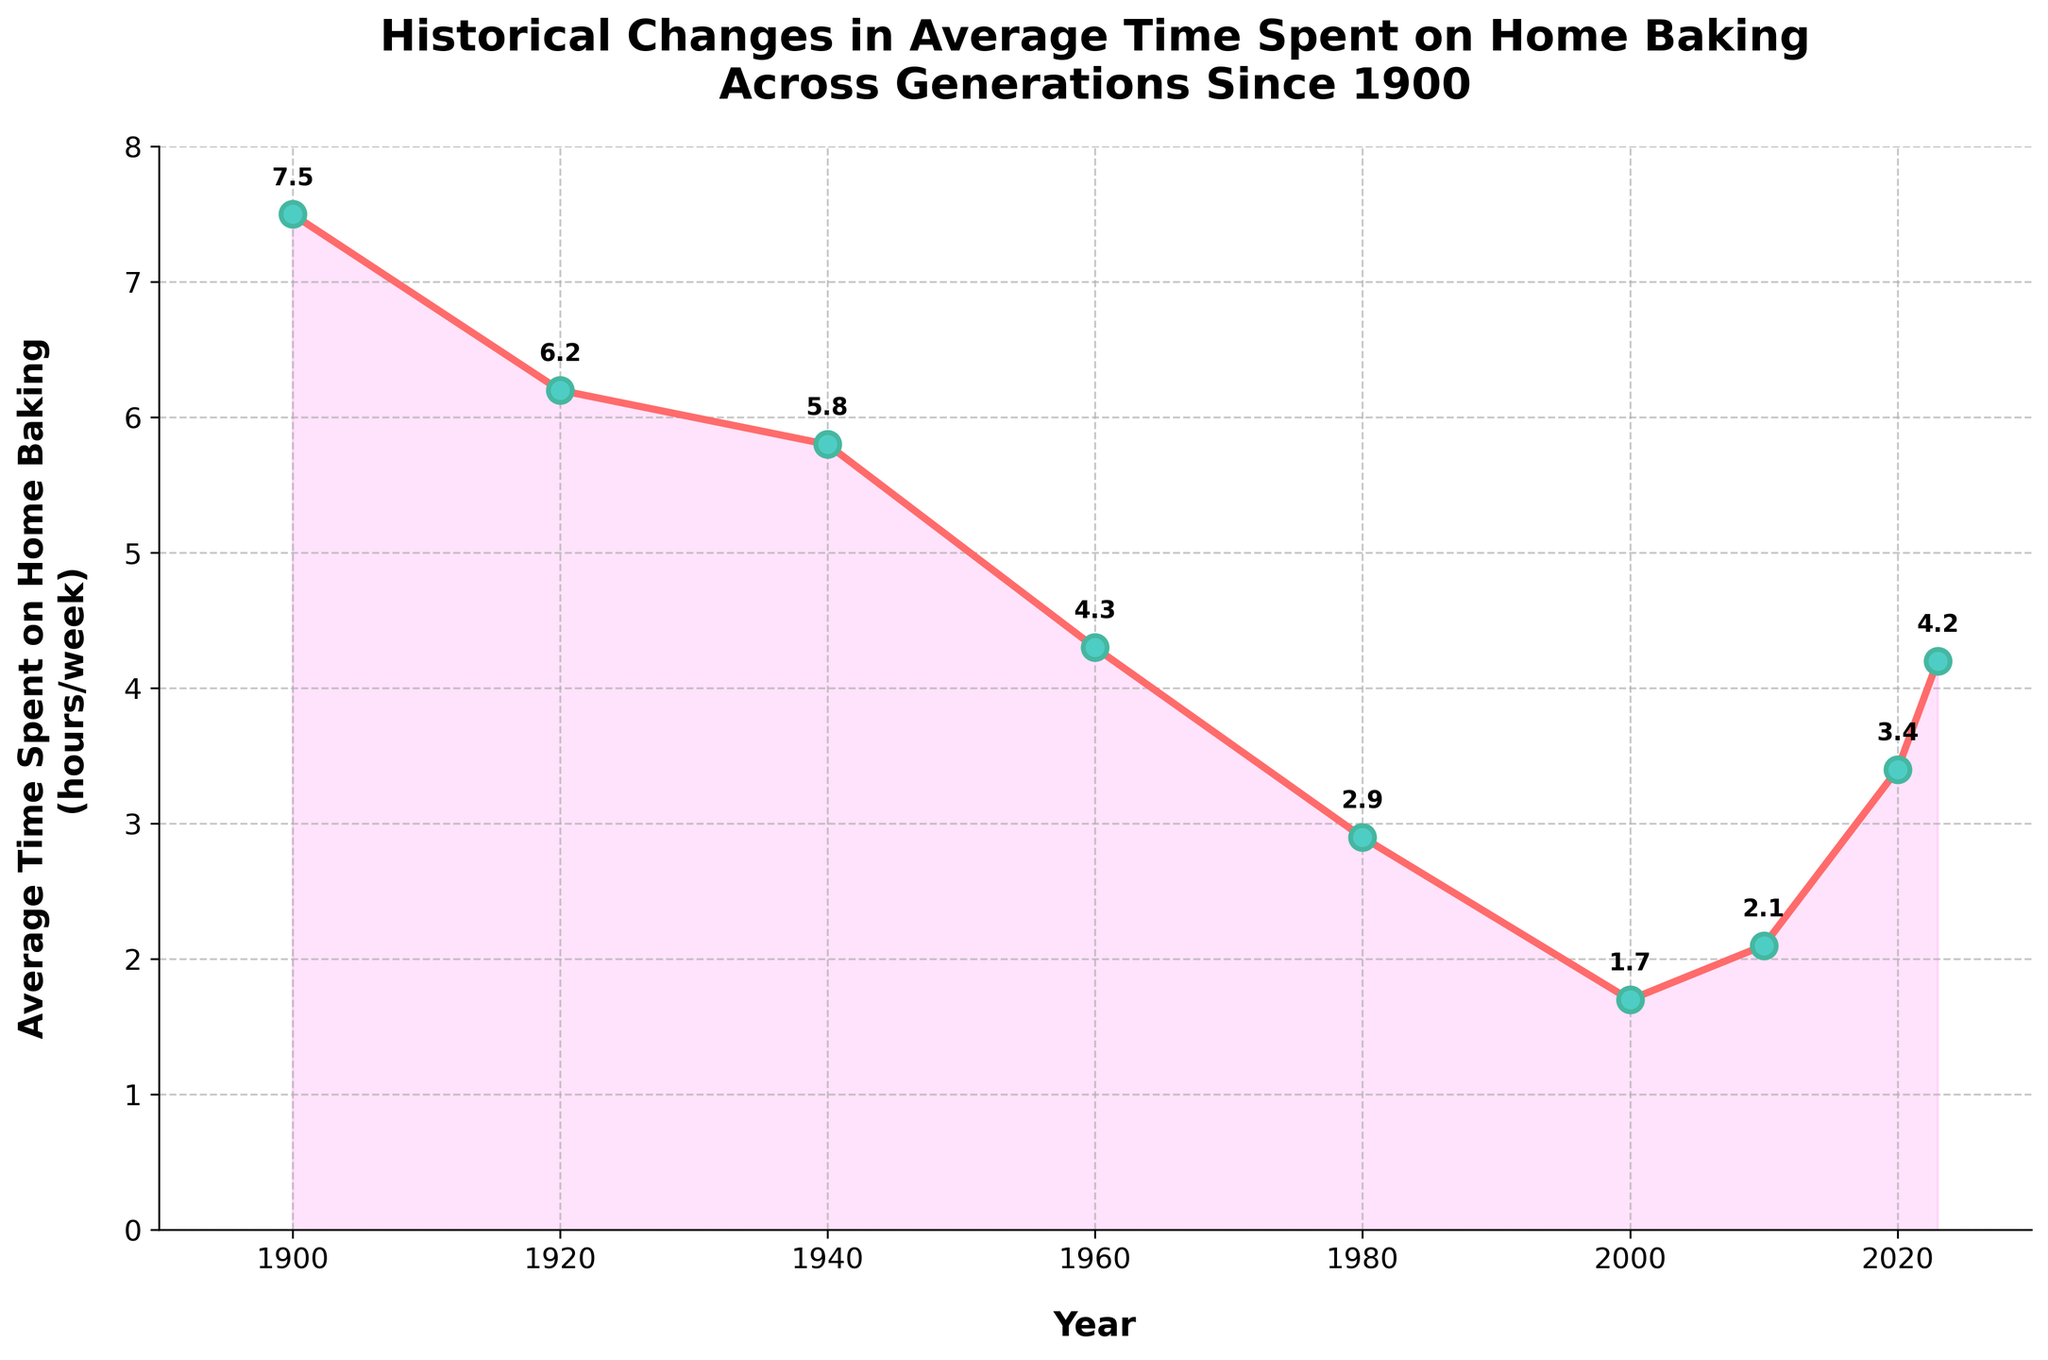What is the average time spent on home baking in 1920? Look at the y-axis value corresponding to the year 1920. The plot shows 6.2 hours/week in this year.
Answer: 6.2 hours/week In which year was the least amount of time spent on home baking? Identify the point on the graph corresponding to the lowest value. The lowest point occurs in 2000, with an average time of 1.7 hours/week.
Answer: 2000 How does the time spent on home baking in 1960 compare to that in 2023? Compare the y-axis values for the years 1960 and 2023. In 1960, it was 4.3 hours/week, and in 2023, it is 4.2 hours/week. 1960 has slightly more time spent.
Answer: 1960 is more What is the difference in time spent on home baking between 1900 and 2000? Subtract the value in 2000 (1.7 hours/week) from the value in 1900 (7.5 hours/week). 7.5 - 1.7 = 5.8 hours.
Answer: 5.8 hours Which decade saw the most significant decrease in time spent on home baking? Observe the trend of the graph and identify the steepest downward slope. The sharpest decline is between 1960 (4.3) and 1980 (2.9), a difference of 1.4 hours.
Answer: 1960 to 1980 By how many hours did the average time spent on home baking increase from 2000 to 2023? Subtract the value in 2000 (1.7 hours/week) from the value in 2023 (4.2 hours/week). 4.2 - 1.7 = 2.5 hours.
Answer: 2.5 hours Explain the overall trend in the average time spent on home baking from 1900 to 1980. From 1900 (7.5) to 1980 (2.9), there is a gradual decrease with notable drops between 1960 and 1980, illustrating a significant declining trend in home baking times.
Answer: Decreasing trend What is the average time spent on home baking across all the years shown in the plot? Add up all the values and divide by the number of years. (7.5 + 6.2 + 5.8 + 4.3 + 2.9 + 1.7 + 2.1 + 3.4 + 4.2) / 9 = 4.01 hours/week.
Answer: 4.01 hours/week 